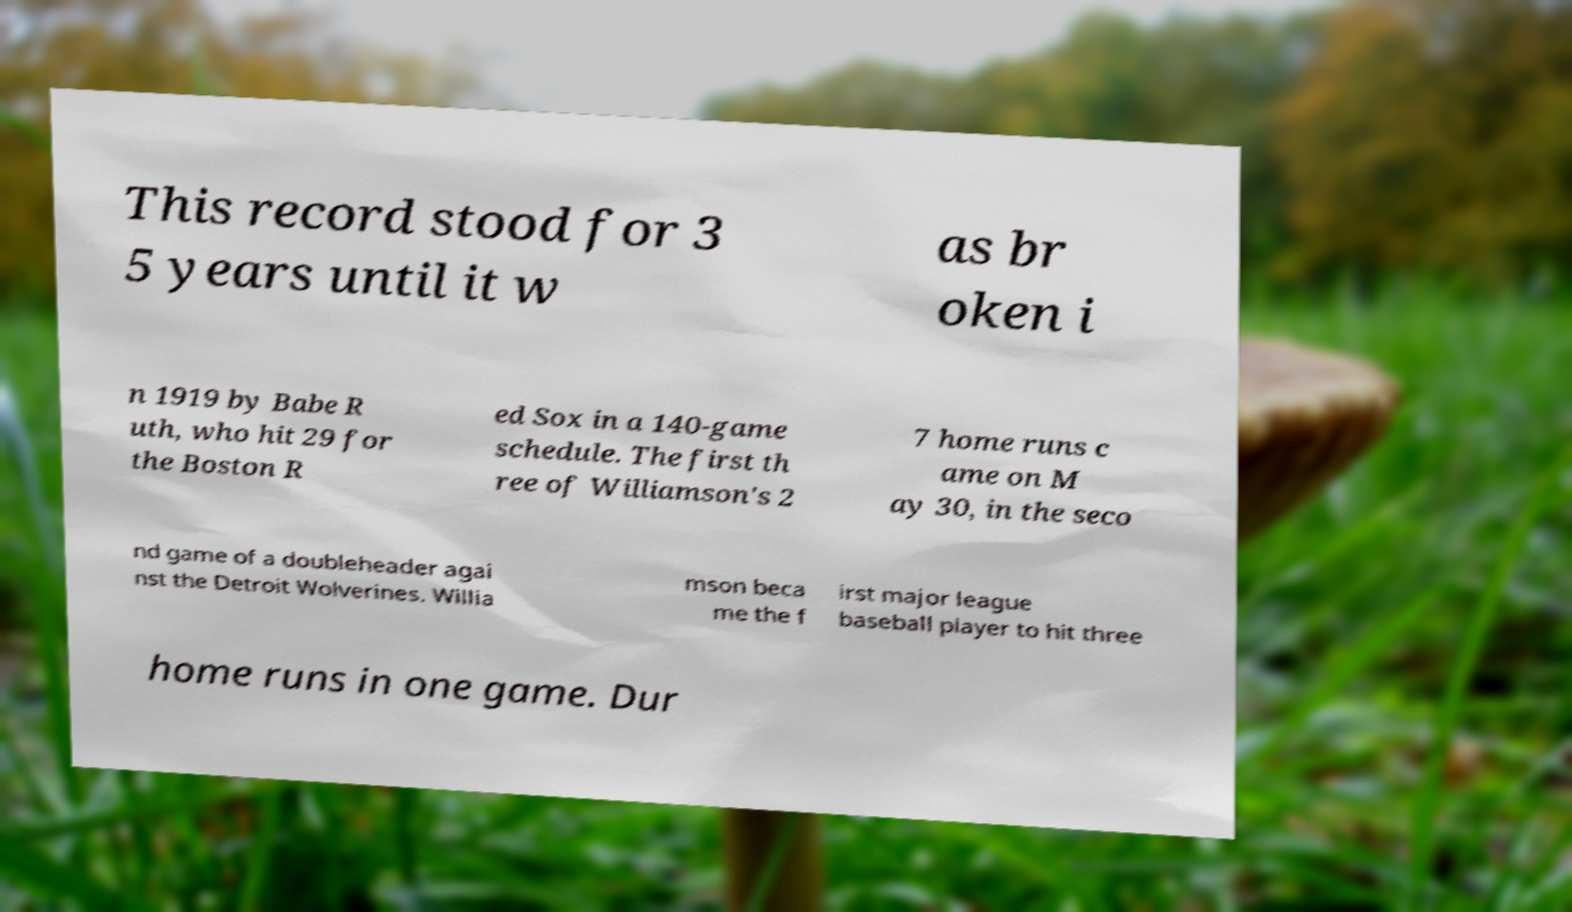Could you extract and type out the text from this image? This record stood for 3 5 years until it w as br oken i n 1919 by Babe R uth, who hit 29 for the Boston R ed Sox in a 140-game schedule. The first th ree of Williamson's 2 7 home runs c ame on M ay 30, in the seco nd game of a doubleheader agai nst the Detroit Wolverines. Willia mson beca me the f irst major league baseball player to hit three home runs in one game. Dur 